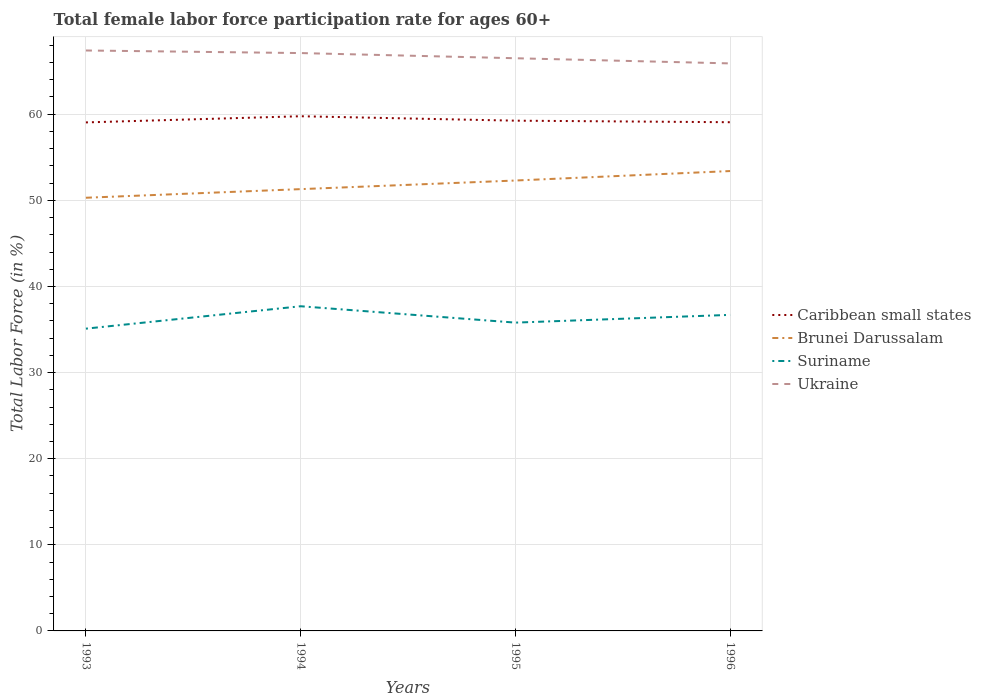How many different coloured lines are there?
Offer a terse response. 4. Across all years, what is the maximum female labor force participation rate in Suriname?
Give a very brief answer. 35.1. In which year was the female labor force participation rate in Caribbean small states maximum?
Offer a terse response. 1993. What is the total female labor force participation rate in Ukraine in the graph?
Ensure brevity in your answer.  1.2. What is the difference between the highest and the second highest female labor force participation rate in Caribbean small states?
Make the answer very short. 0.72. What is the difference between the highest and the lowest female labor force participation rate in Caribbean small states?
Offer a very short reply. 1. Is the female labor force participation rate in Brunei Darussalam strictly greater than the female labor force participation rate in Ukraine over the years?
Make the answer very short. Yes. How many lines are there?
Offer a very short reply. 4. What is the difference between two consecutive major ticks on the Y-axis?
Make the answer very short. 10. Are the values on the major ticks of Y-axis written in scientific E-notation?
Ensure brevity in your answer.  No. Does the graph contain any zero values?
Give a very brief answer. No. Where does the legend appear in the graph?
Your response must be concise. Center right. What is the title of the graph?
Offer a very short reply. Total female labor force participation rate for ages 60+. Does "Belgium" appear as one of the legend labels in the graph?
Your response must be concise. No. What is the label or title of the X-axis?
Provide a succinct answer. Years. What is the Total Labor Force (in %) in Caribbean small states in 1993?
Provide a succinct answer. 59.05. What is the Total Labor Force (in %) in Brunei Darussalam in 1993?
Provide a succinct answer. 50.3. What is the Total Labor Force (in %) in Suriname in 1993?
Provide a short and direct response. 35.1. What is the Total Labor Force (in %) of Ukraine in 1993?
Your answer should be compact. 67.4. What is the Total Labor Force (in %) in Caribbean small states in 1994?
Offer a terse response. 59.76. What is the Total Labor Force (in %) in Brunei Darussalam in 1994?
Your answer should be very brief. 51.3. What is the Total Labor Force (in %) of Suriname in 1994?
Provide a succinct answer. 37.7. What is the Total Labor Force (in %) in Ukraine in 1994?
Give a very brief answer. 67.1. What is the Total Labor Force (in %) of Caribbean small states in 1995?
Provide a short and direct response. 59.25. What is the Total Labor Force (in %) of Brunei Darussalam in 1995?
Give a very brief answer. 52.3. What is the Total Labor Force (in %) in Suriname in 1995?
Provide a short and direct response. 35.8. What is the Total Labor Force (in %) of Ukraine in 1995?
Offer a very short reply. 66.5. What is the Total Labor Force (in %) of Caribbean small states in 1996?
Your response must be concise. 59.07. What is the Total Labor Force (in %) in Brunei Darussalam in 1996?
Make the answer very short. 53.4. What is the Total Labor Force (in %) in Suriname in 1996?
Give a very brief answer. 36.7. What is the Total Labor Force (in %) in Ukraine in 1996?
Keep it short and to the point. 65.9. Across all years, what is the maximum Total Labor Force (in %) in Caribbean small states?
Ensure brevity in your answer.  59.76. Across all years, what is the maximum Total Labor Force (in %) of Brunei Darussalam?
Give a very brief answer. 53.4. Across all years, what is the maximum Total Labor Force (in %) of Suriname?
Provide a short and direct response. 37.7. Across all years, what is the maximum Total Labor Force (in %) of Ukraine?
Make the answer very short. 67.4. Across all years, what is the minimum Total Labor Force (in %) in Caribbean small states?
Provide a short and direct response. 59.05. Across all years, what is the minimum Total Labor Force (in %) of Brunei Darussalam?
Offer a very short reply. 50.3. Across all years, what is the minimum Total Labor Force (in %) in Suriname?
Your response must be concise. 35.1. Across all years, what is the minimum Total Labor Force (in %) in Ukraine?
Give a very brief answer. 65.9. What is the total Total Labor Force (in %) in Caribbean small states in the graph?
Give a very brief answer. 237.13. What is the total Total Labor Force (in %) in Brunei Darussalam in the graph?
Your answer should be compact. 207.3. What is the total Total Labor Force (in %) in Suriname in the graph?
Give a very brief answer. 145.3. What is the total Total Labor Force (in %) of Ukraine in the graph?
Provide a succinct answer. 266.9. What is the difference between the Total Labor Force (in %) in Caribbean small states in 1993 and that in 1994?
Provide a short and direct response. -0.72. What is the difference between the Total Labor Force (in %) of Brunei Darussalam in 1993 and that in 1994?
Keep it short and to the point. -1. What is the difference between the Total Labor Force (in %) of Suriname in 1993 and that in 1994?
Your response must be concise. -2.6. What is the difference between the Total Labor Force (in %) in Ukraine in 1993 and that in 1994?
Provide a succinct answer. 0.3. What is the difference between the Total Labor Force (in %) of Caribbean small states in 1993 and that in 1995?
Your response must be concise. -0.2. What is the difference between the Total Labor Force (in %) of Suriname in 1993 and that in 1995?
Your answer should be compact. -0.7. What is the difference between the Total Labor Force (in %) in Caribbean small states in 1993 and that in 1996?
Offer a terse response. -0.02. What is the difference between the Total Labor Force (in %) of Brunei Darussalam in 1993 and that in 1996?
Provide a short and direct response. -3.1. What is the difference between the Total Labor Force (in %) of Suriname in 1993 and that in 1996?
Provide a succinct answer. -1.6. What is the difference between the Total Labor Force (in %) in Caribbean small states in 1994 and that in 1995?
Your response must be concise. 0.51. What is the difference between the Total Labor Force (in %) of Suriname in 1994 and that in 1995?
Ensure brevity in your answer.  1.9. What is the difference between the Total Labor Force (in %) in Caribbean small states in 1994 and that in 1996?
Ensure brevity in your answer.  0.69. What is the difference between the Total Labor Force (in %) of Brunei Darussalam in 1994 and that in 1996?
Provide a short and direct response. -2.1. What is the difference between the Total Labor Force (in %) in Ukraine in 1994 and that in 1996?
Offer a terse response. 1.2. What is the difference between the Total Labor Force (in %) in Caribbean small states in 1995 and that in 1996?
Offer a terse response. 0.18. What is the difference between the Total Labor Force (in %) of Brunei Darussalam in 1995 and that in 1996?
Ensure brevity in your answer.  -1.1. What is the difference between the Total Labor Force (in %) of Suriname in 1995 and that in 1996?
Your answer should be very brief. -0.9. What is the difference between the Total Labor Force (in %) in Caribbean small states in 1993 and the Total Labor Force (in %) in Brunei Darussalam in 1994?
Provide a short and direct response. 7.75. What is the difference between the Total Labor Force (in %) of Caribbean small states in 1993 and the Total Labor Force (in %) of Suriname in 1994?
Keep it short and to the point. 21.35. What is the difference between the Total Labor Force (in %) in Caribbean small states in 1993 and the Total Labor Force (in %) in Ukraine in 1994?
Provide a succinct answer. -8.05. What is the difference between the Total Labor Force (in %) of Brunei Darussalam in 1993 and the Total Labor Force (in %) of Suriname in 1994?
Your answer should be very brief. 12.6. What is the difference between the Total Labor Force (in %) in Brunei Darussalam in 1993 and the Total Labor Force (in %) in Ukraine in 1994?
Provide a succinct answer. -16.8. What is the difference between the Total Labor Force (in %) of Suriname in 1993 and the Total Labor Force (in %) of Ukraine in 1994?
Provide a succinct answer. -32. What is the difference between the Total Labor Force (in %) in Caribbean small states in 1993 and the Total Labor Force (in %) in Brunei Darussalam in 1995?
Offer a very short reply. 6.75. What is the difference between the Total Labor Force (in %) of Caribbean small states in 1993 and the Total Labor Force (in %) of Suriname in 1995?
Your response must be concise. 23.25. What is the difference between the Total Labor Force (in %) in Caribbean small states in 1993 and the Total Labor Force (in %) in Ukraine in 1995?
Offer a very short reply. -7.45. What is the difference between the Total Labor Force (in %) in Brunei Darussalam in 1993 and the Total Labor Force (in %) in Suriname in 1995?
Your answer should be very brief. 14.5. What is the difference between the Total Labor Force (in %) in Brunei Darussalam in 1993 and the Total Labor Force (in %) in Ukraine in 1995?
Give a very brief answer. -16.2. What is the difference between the Total Labor Force (in %) in Suriname in 1993 and the Total Labor Force (in %) in Ukraine in 1995?
Offer a terse response. -31.4. What is the difference between the Total Labor Force (in %) in Caribbean small states in 1993 and the Total Labor Force (in %) in Brunei Darussalam in 1996?
Offer a very short reply. 5.65. What is the difference between the Total Labor Force (in %) in Caribbean small states in 1993 and the Total Labor Force (in %) in Suriname in 1996?
Make the answer very short. 22.35. What is the difference between the Total Labor Force (in %) of Caribbean small states in 1993 and the Total Labor Force (in %) of Ukraine in 1996?
Offer a very short reply. -6.85. What is the difference between the Total Labor Force (in %) of Brunei Darussalam in 1993 and the Total Labor Force (in %) of Suriname in 1996?
Keep it short and to the point. 13.6. What is the difference between the Total Labor Force (in %) in Brunei Darussalam in 1993 and the Total Labor Force (in %) in Ukraine in 1996?
Make the answer very short. -15.6. What is the difference between the Total Labor Force (in %) of Suriname in 1993 and the Total Labor Force (in %) of Ukraine in 1996?
Offer a very short reply. -30.8. What is the difference between the Total Labor Force (in %) of Caribbean small states in 1994 and the Total Labor Force (in %) of Brunei Darussalam in 1995?
Give a very brief answer. 7.46. What is the difference between the Total Labor Force (in %) of Caribbean small states in 1994 and the Total Labor Force (in %) of Suriname in 1995?
Provide a succinct answer. 23.96. What is the difference between the Total Labor Force (in %) of Caribbean small states in 1994 and the Total Labor Force (in %) of Ukraine in 1995?
Your answer should be compact. -6.74. What is the difference between the Total Labor Force (in %) of Brunei Darussalam in 1994 and the Total Labor Force (in %) of Ukraine in 1995?
Your answer should be compact. -15.2. What is the difference between the Total Labor Force (in %) of Suriname in 1994 and the Total Labor Force (in %) of Ukraine in 1995?
Ensure brevity in your answer.  -28.8. What is the difference between the Total Labor Force (in %) of Caribbean small states in 1994 and the Total Labor Force (in %) of Brunei Darussalam in 1996?
Make the answer very short. 6.36. What is the difference between the Total Labor Force (in %) in Caribbean small states in 1994 and the Total Labor Force (in %) in Suriname in 1996?
Make the answer very short. 23.06. What is the difference between the Total Labor Force (in %) in Caribbean small states in 1994 and the Total Labor Force (in %) in Ukraine in 1996?
Make the answer very short. -6.14. What is the difference between the Total Labor Force (in %) of Brunei Darussalam in 1994 and the Total Labor Force (in %) of Ukraine in 1996?
Ensure brevity in your answer.  -14.6. What is the difference between the Total Labor Force (in %) of Suriname in 1994 and the Total Labor Force (in %) of Ukraine in 1996?
Your answer should be very brief. -28.2. What is the difference between the Total Labor Force (in %) in Caribbean small states in 1995 and the Total Labor Force (in %) in Brunei Darussalam in 1996?
Provide a succinct answer. 5.85. What is the difference between the Total Labor Force (in %) in Caribbean small states in 1995 and the Total Labor Force (in %) in Suriname in 1996?
Your response must be concise. 22.55. What is the difference between the Total Labor Force (in %) in Caribbean small states in 1995 and the Total Labor Force (in %) in Ukraine in 1996?
Your answer should be compact. -6.65. What is the difference between the Total Labor Force (in %) of Brunei Darussalam in 1995 and the Total Labor Force (in %) of Suriname in 1996?
Ensure brevity in your answer.  15.6. What is the difference between the Total Labor Force (in %) of Suriname in 1995 and the Total Labor Force (in %) of Ukraine in 1996?
Your response must be concise. -30.1. What is the average Total Labor Force (in %) in Caribbean small states per year?
Provide a short and direct response. 59.28. What is the average Total Labor Force (in %) of Brunei Darussalam per year?
Make the answer very short. 51.83. What is the average Total Labor Force (in %) of Suriname per year?
Provide a short and direct response. 36.33. What is the average Total Labor Force (in %) in Ukraine per year?
Give a very brief answer. 66.72. In the year 1993, what is the difference between the Total Labor Force (in %) of Caribbean small states and Total Labor Force (in %) of Brunei Darussalam?
Provide a succinct answer. 8.75. In the year 1993, what is the difference between the Total Labor Force (in %) of Caribbean small states and Total Labor Force (in %) of Suriname?
Make the answer very short. 23.95. In the year 1993, what is the difference between the Total Labor Force (in %) of Caribbean small states and Total Labor Force (in %) of Ukraine?
Ensure brevity in your answer.  -8.35. In the year 1993, what is the difference between the Total Labor Force (in %) of Brunei Darussalam and Total Labor Force (in %) of Ukraine?
Provide a succinct answer. -17.1. In the year 1993, what is the difference between the Total Labor Force (in %) of Suriname and Total Labor Force (in %) of Ukraine?
Provide a short and direct response. -32.3. In the year 1994, what is the difference between the Total Labor Force (in %) of Caribbean small states and Total Labor Force (in %) of Brunei Darussalam?
Provide a short and direct response. 8.46. In the year 1994, what is the difference between the Total Labor Force (in %) in Caribbean small states and Total Labor Force (in %) in Suriname?
Your response must be concise. 22.06. In the year 1994, what is the difference between the Total Labor Force (in %) in Caribbean small states and Total Labor Force (in %) in Ukraine?
Provide a short and direct response. -7.34. In the year 1994, what is the difference between the Total Labor Force (in %) of Brunei Darussalam and Total Labor Force (in %) of Suriname?
Provide a succinct answer. 13.6. In the year 1994, what is the difference between the Total Labor Force (in %) of Brunei Darussalam and Total Labor Force (in %) of Ukraine?
Offer a terse response. -15.8. In the year 1994, what is the difference between the Total Labor Force (in %) of Suriname and Total Labor Force (in %) of Ukraine?
Give a very brief answer. -29.4. In the year 1995, what is the difference between the Total Labor Force (in %) in Caribbean small states and Total Labor Force (in %) in Brunei Darussalam?
Offer a terse response. 6.95. In the year 1995, what is the difference between the Total Labor Force (in %) in Caribbean small states and Total Labor Force (in %) in Suriname?
Your response must be concise. 23.45. In the year 1995, what is the difference between the Total Labor Force (in %) of Caribbean small states and Total Labor Force (in %) of Ukraine?
Your answer should be compact. -7.25. In the year 1995, what is the difference between the Total Labor Force (in %) in Brunei Darussalam and Total Labor Force (in %) in Ukraine?
Give a very brief answer. -14.2. In the year 1995, what is the difference between the Total Labor Force (in %) in Suriname and Total Labor Force (in %) in Ukraine?
Provide a short and direct response. -30.7. In the year 1996, what is the difference between the Total Labor Force (in %) of Caribbean small states and Total Labor Force (in %) of Brunei Darussalam?
Give a very brief answer. 5.67. In the year 1996, what is the difference between the Total Labor Force (in %) in Caribbean small states and Total Labor Force (in %) in Suriname?
Your response must be concise. 22.37. In the year 1996, what is the difference between the Total Labor Force (in %) of Caribbean small states and Total Labor Force (in %) of Ukraine?
Make the answer very short. -6.83. In the year 1996, what is the difference between the Total Labor Force (in %) in Brunei Darussalam and Total Labor Force (in %) in Ukraine?
Offer a terse response. -12.5. In the year 1996, what is the difference between the Total Labor Force (in %) of Suriname and Total Labor Force (in %) of Ukraine?
Your answer should be very brief. -29.2. What is the ratio of the Total Labor Force (in %) of Brunei Darussalam in 1993 to that in 1994?
Your answer should be very brief. 0.98. What is the ratio of the Total Labor Force (in %) of Suriname in 1993 to that in 1994?
Provide a short and direct response. 0.93. What is the ratio of the Total Labor Force (in %) in Brunei Darussalam in 1993 to that in 1995?
Your response must be concise. 0.96. What is the ratio of the Total Labor Force (in %) of Suriname in 1993 to that in 1995?
Your answer should be very brief. 0.98. What is the ratio of the Total Labor Force (in %) of Ukraine in 1993 to that in 1995?
Provide a succinct answer. 1.01. What is the ratio of the Total Labor Force (in %) in Caribbean small states in 1993 to that in 1996?
Make the answer very short. 1. What is the ratio of the Total Labor Force (in %) of Brunei Darussalam in 1993 to that in 1996?
Give a very brief answer. 0.94. What is the ratio of the Total Labor Force (in %) of Suriname in 1993 to that in 1996?
Give a very brief answer. 0.96. What is the ratio of the Total Labor Force (in %) in Ukraine in 1993 to that in 1996?
Your answer should be compact. 1.02. What is the ratio of the Total Labor Force (in %) of Caribbean small states in 1994 to that in 1995?
Offer a terse response. 1.01. What is the ratio of the Total Labor Force (in %) in Brunei Darussalam in 1994 to that in 1995?
Keep it short and to the point. 0.98. What is the ratio of the Total Labor Force (in %) of Suriname in 1994 to that in 1995?
Ensure brevity in your answer.  1.05. What is the ratio of the Total Labor Force (in %) in Ukraine in 1994 to that in 1995?
Provide a succinct answer. 1.01. What is the ratio of the Total Labor Force (in %) of Caribbean small states in 1994 to that in 1996?
Offer a terse response. 1.01. What is the ratio of the Total Labor Force (in %) of Brunei Darussalam in 1994 to that in 1996?
Give a very brief answer. 0.96. What is the ratio of the Total Labor Force (in %) of Suriname in 1994 to that in 1996?
Make the answer very short. 1.03. What is the ratio of the Total Labor Force (in %) of Ukraine in 1994 to that in 1996?
Your answer should be very brief. 1.02. What is the ratio of the Total Labor Force (in %) in Brunei Darussalam in 1995 to that in 1996?
Provide a succinct answer. 0.98. What is the ratio of the Total Labor Force (in %) in Suriname in 1995 to that in 1996?
Give a very brief answer. 0.98. What is the ratio of the Total Labor Force (in %) of Ukraine in 1995 to that in 1996?
Offer a terse response. 1.01. What is the difference between the highest and the second highest Total Labor Force (in %) of Caribbean small states?
Give a very brief answer. 0.51. What is the difference between the highest and the second highest Total Labor Force (in %) of Suriname?
Provide a succinct answer. 1. What is the difference between the highest and the second highest Total Labor Force (in %) in Ukraine?
Offer a very short reply. 0.3. What is the difference between the highest and the lowest Total Labor Force (in %) of Caribbean small states?
Make the answer very short. 0.72. What is the difference between the highest and the lowest Total Labor Force (in %) in Suriname?
Ensure brevity in your answer.  2.6. 